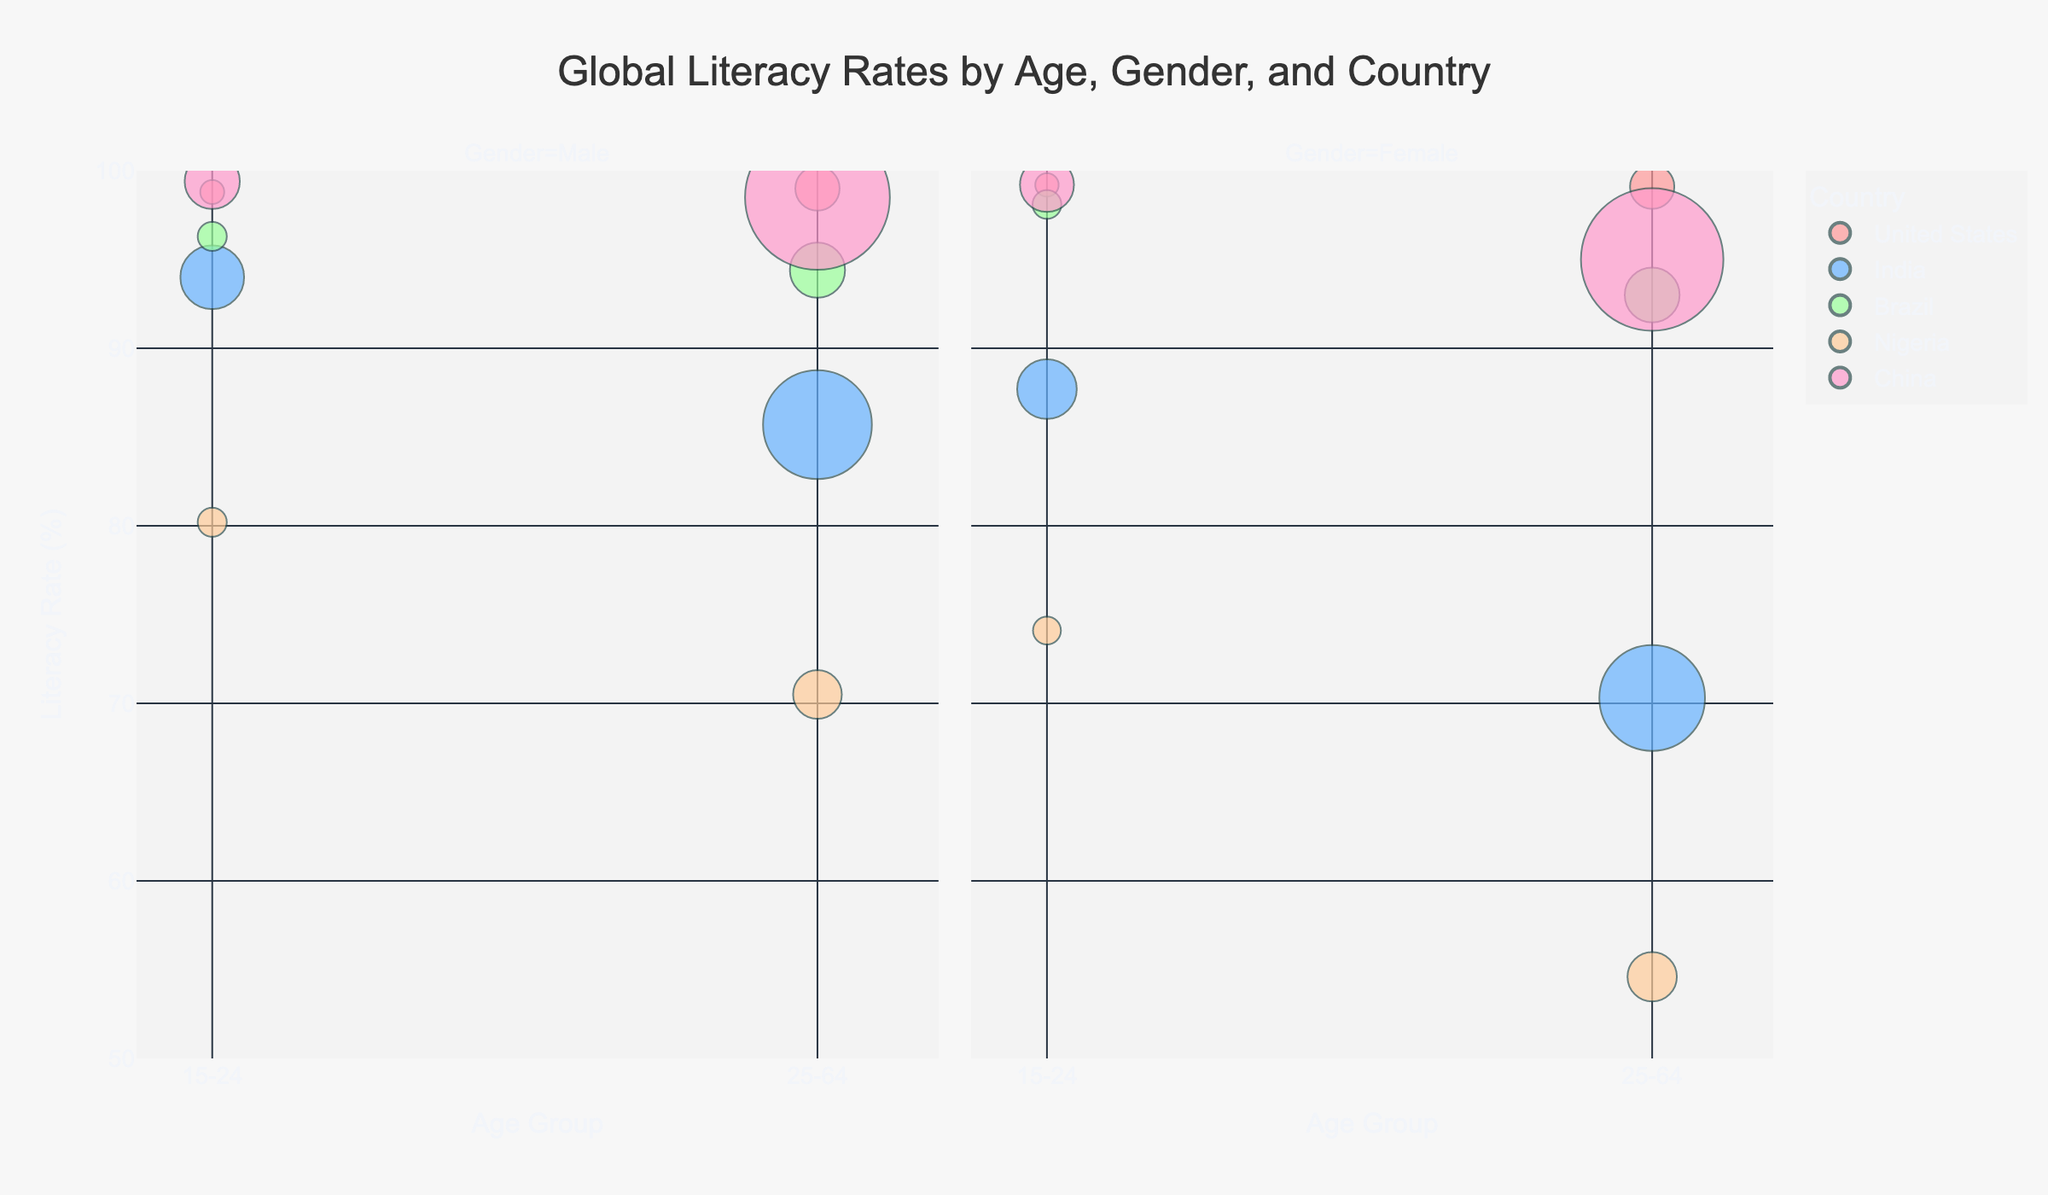What's the overall title of the chart? The title of the chart is displayed at the top center of the figure and it reads "Global Literacy Rates by Age, Gender, and Country".
Answer: Global Literacy Rates by Age, Gender, and Country What are the two age groups represented on the x-axis? The x-axis is labeled "Age Group" and shows two age groups: "15-24" and "25-64".
Answer: 15-24, 25-64 Which country has the highest literacy rate for females aged 15-24? Looking at the bubbles in the facet for females and age group 15-24, the highest bubble is for "United States", which has a literacy rate of 99.2%.
Answer: United States Which gender has higher literacy rates in India for the age group 25-64? Compare the dots for males and females in India for the age group 25-64 in their respective facets. Males have a literacy rate of 85.7%, whereas females have 70.3%.
Answer: Male Among all countries displayed, which one has the largest population size for the age group 15-24? Observe the size of the bubbles for each country in the age group 15-24. The largest bubble corresponds to "India", indicating it has the largest population for this age group.
Answer: India Compare the literacy rates for males aged 15-24 in Brazil and Nigeria. Which is higher? In the male facet and age group 15-24, identify the position of the bubbles for "Brazil" and "Nigeria". Brazil has a literacy rate of 96.3%, whereas Nigeria has 80.2%.
Answer: Brazil What's the average literacy rate for females aged 25-64 in Brazil and China? Locate the bubbles for females aged 25-64 in both Brazil and China. Brazil has 93.0% and China has 95.0%. The average is calculated as (93.0 + 95.0) / 2 = 94.0.
Answer: 94.0 Which country shows the highest disparity in literacy rates between genders for the age group 25-64? Compare the difference between male and female literacy rates for the age group 25-64 for each country. Nigeria shows a high disparity: males 70.5% and females 54.6%, with a difference of 15.9 percentage points.
Answer: Nigeria Are literacy rates generally higher for the age group 15-24 or 25-64 across the countries shown? Compare the general position of the bubbles for both age groups in each country's facet. The bubbles for the 15-24 age group appear higher overall compared to those for the 25-64 age group.
Answer: 15-24 Which country has the smallest bubble in the chart and what age group and gender does it belong to? Identify the smallest bubble across the entire chart, which appears in the segment for the United States, females aged 15-24, with a population size of 16200000.
Answer: United States, 15-24, Female 